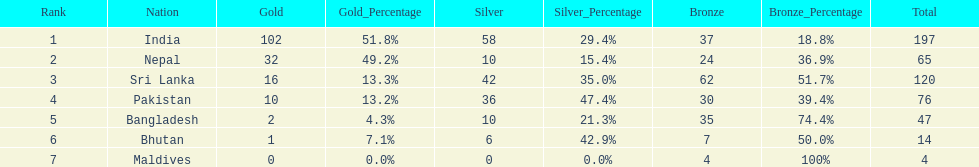Which nation has earned the least amount of gold medals? Maldives. 